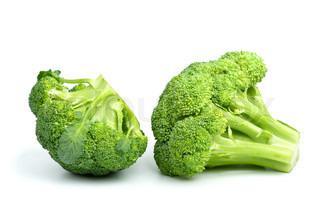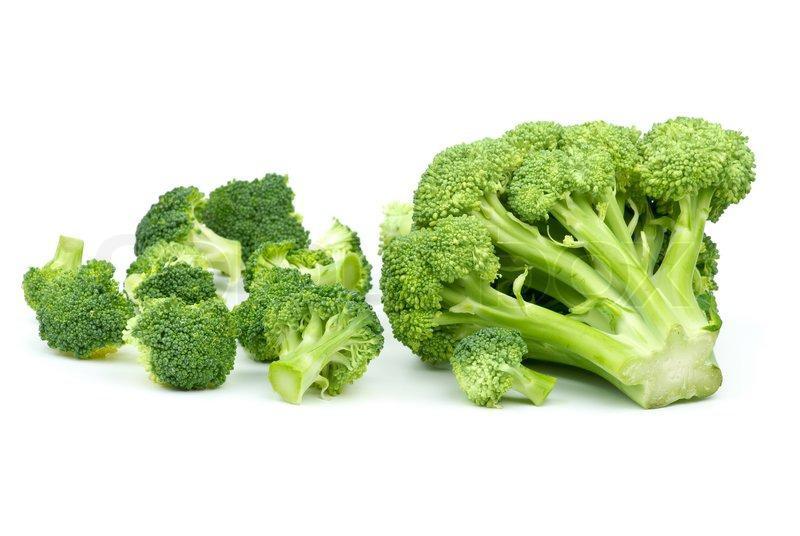The first image is the image on the left, the second image is the image on the right. For the images displayed, is the sentence "One image shows broccoli on a wooden cutting board." factually correct? Answer yes or no. No. 